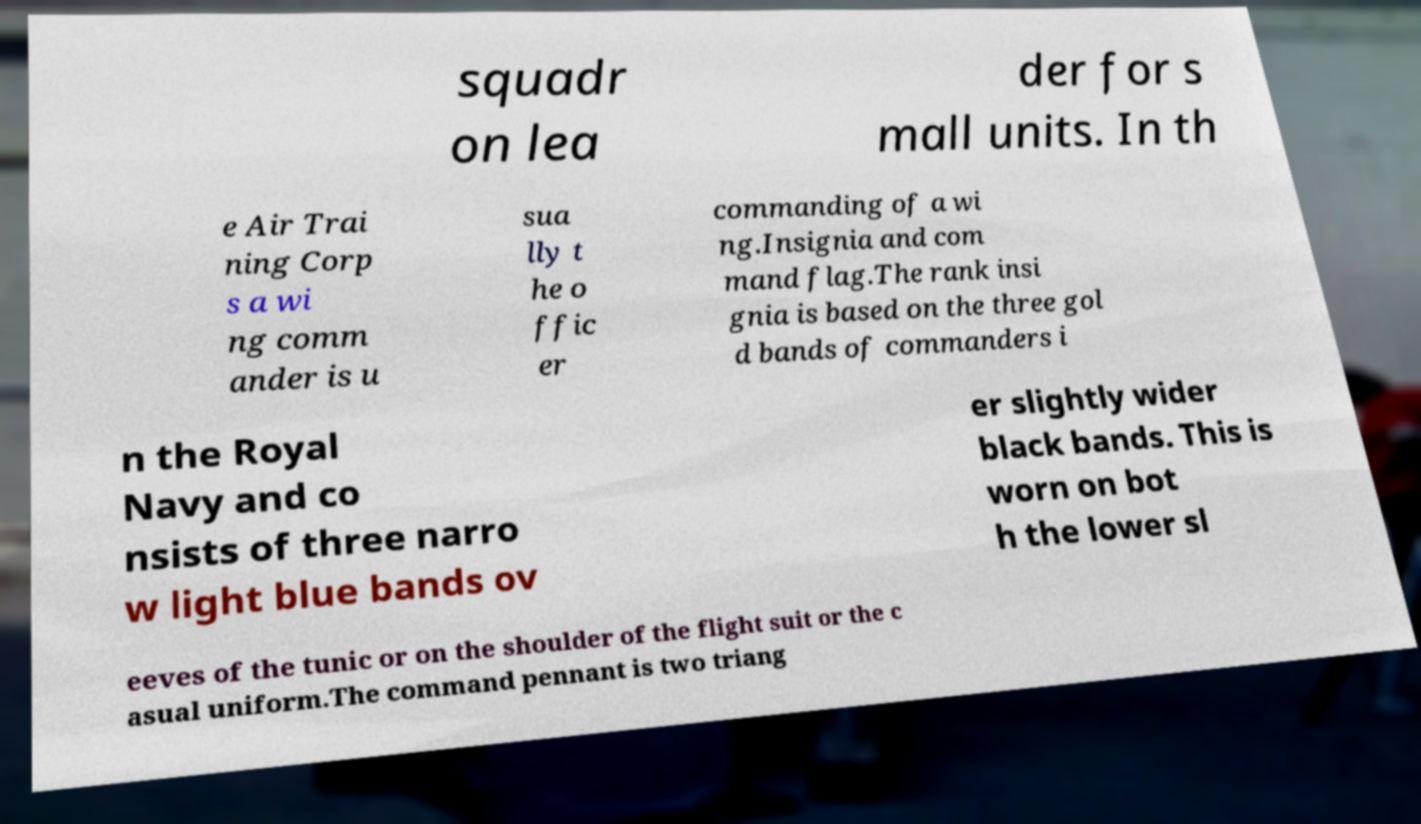Could you assist in decoding the text presented in this image and type it out clearly? squadr on lea der for s mall units. In th e Air Trai ning Corp s a wi ng comm ander is u sua lly t he o ffic er commanding of a wi ng.Insignia and com mand flag.The rank insi gnia is based on the three gol d bands of commanders i n the Royal Navy and co nsists of three narro w light blue bands ov er slightly wider black bands. This is worn on bot h the lower sl eeves of the tunic or on the shoulder of the flight suit or the c asual uniform.The command pennant is two triang 